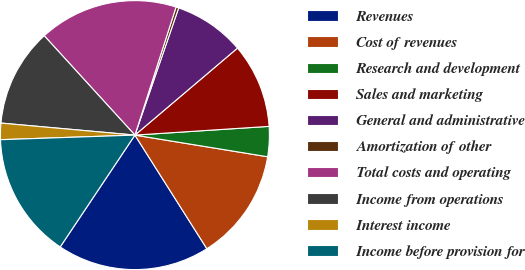Convert chart to OTSL. <chart><loc_0><loc_0><loc_500><loc_500><pie_chart><fcel>Revenues<fcel>Cost of revenues<fcel>Research and development<fcel>Sales and marketing<fcel>General and administrative<fcel>Amortization of other<fcel>Total costs and operating<fcel>Income from operations<fcel>Interest income<fcel>Income before provision for<nl><fcel>18.36%<fcel>13.44%<fcel>3.61%<fcel>10.16%<fcel>8.53%<fcel>0.33%<fcel>16.72%<fcel>11.8%<fcel>1.97%<fcel>15.08%<nl></chart> 